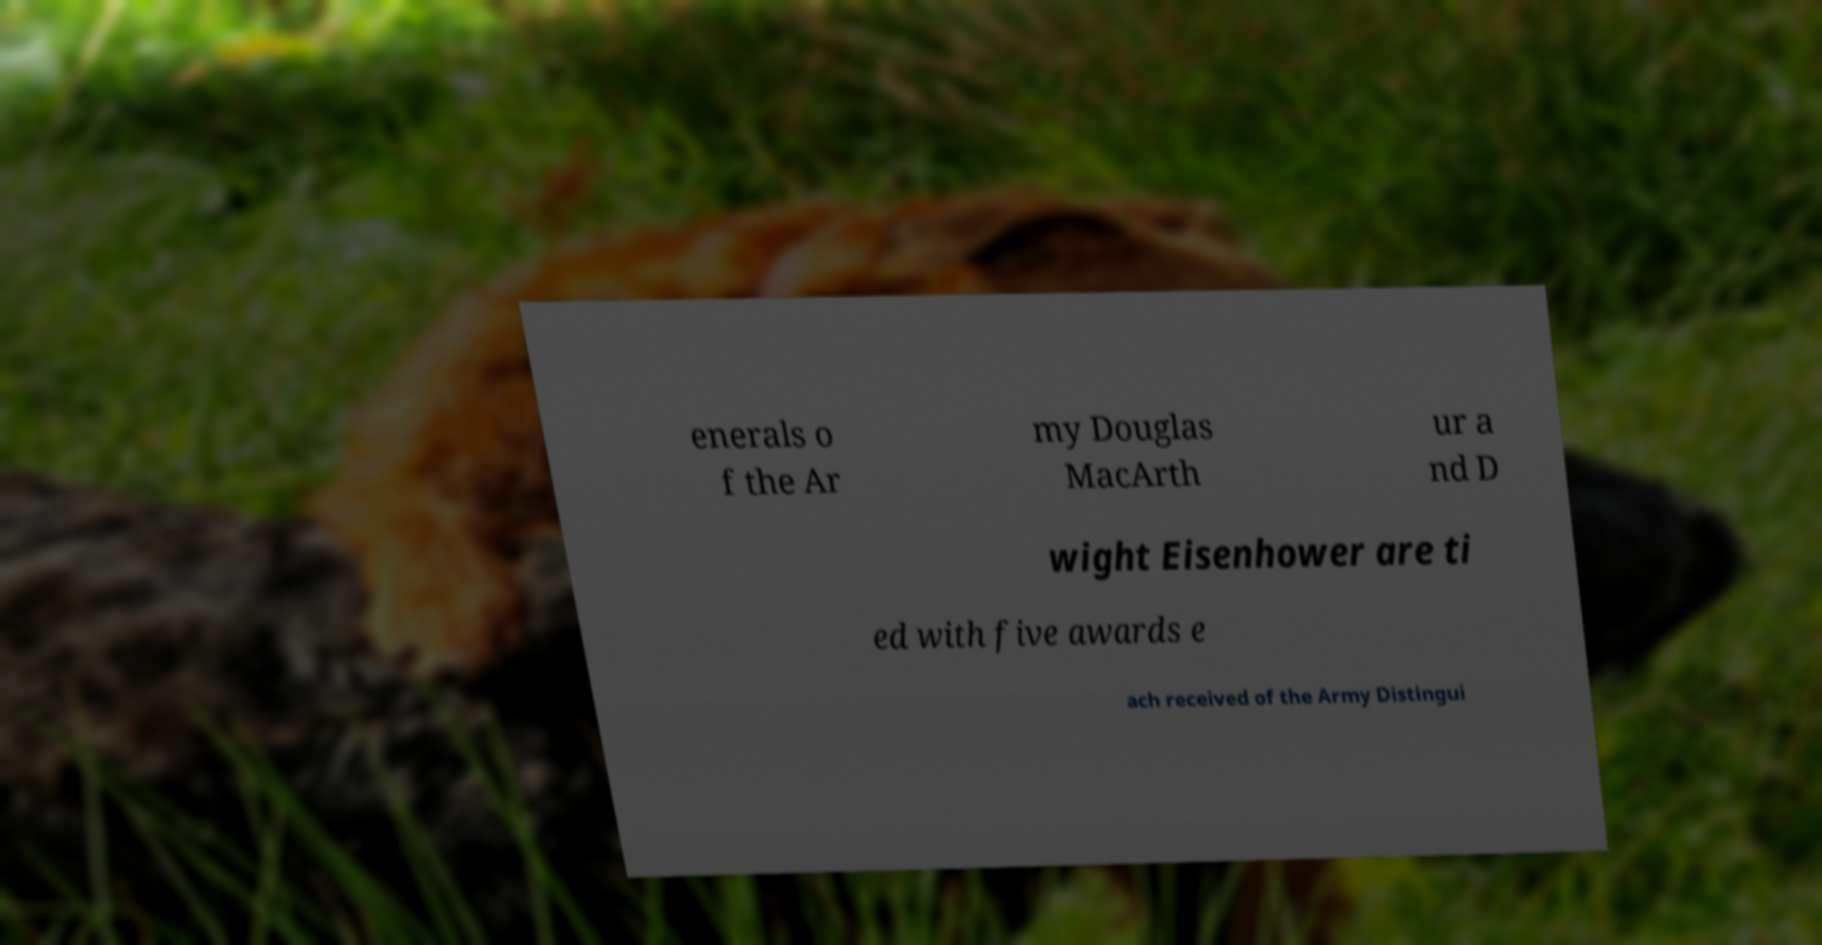I need the written content from this picture converted into text. Can you do that? enerals o f the Ar my Douglas MacArth ur a nd D wight Eisenhower are ti ed with five awards e ach received of the Army Distingui 